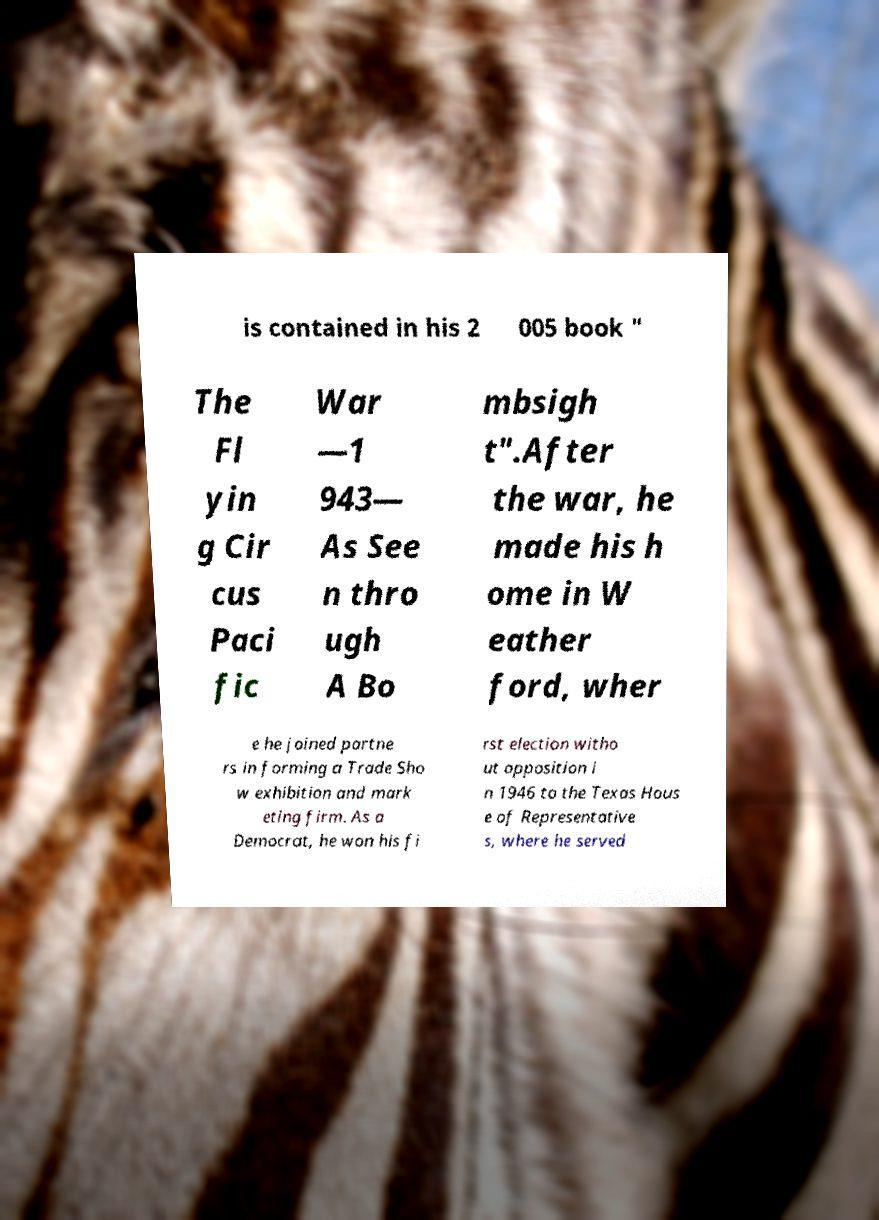Could you assist in decoding the text presented in this image and type it out clearly? is contained in his 2 005 book " The Fl yin g Cir cus Paci fic War —1 943— As See n thro ugh A Bo mbsigh t".After the war, he made his h ome in W eather ford, wher e he joined partne rs in forming a Trade Sho w exhibition and mark eting firm. As a Democrat, he won his fi rst election witho ut opposition i n 1946 to the Texas Hous e of Representative s, where he served 